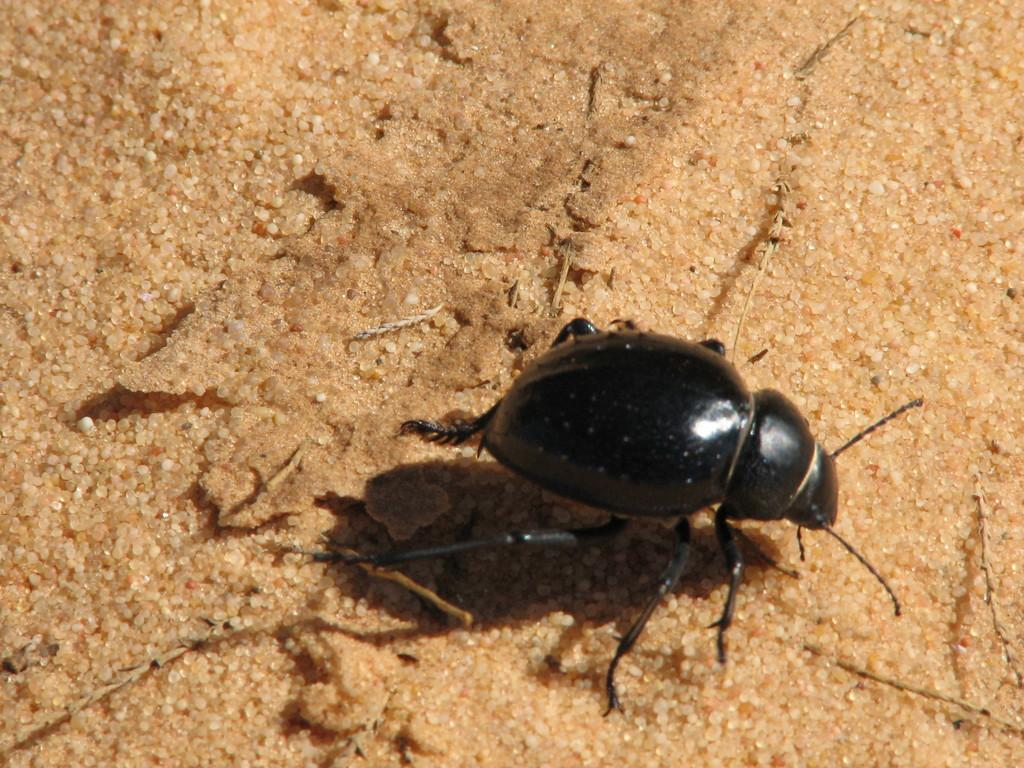What type of creature can be seen in the image? There is an insect in the image. What type of company is operating the playground in the image? There is no company or playground present in the image; it features an insect. How many pies are visible in the image? There are no pies present in the image; it features an insect. 